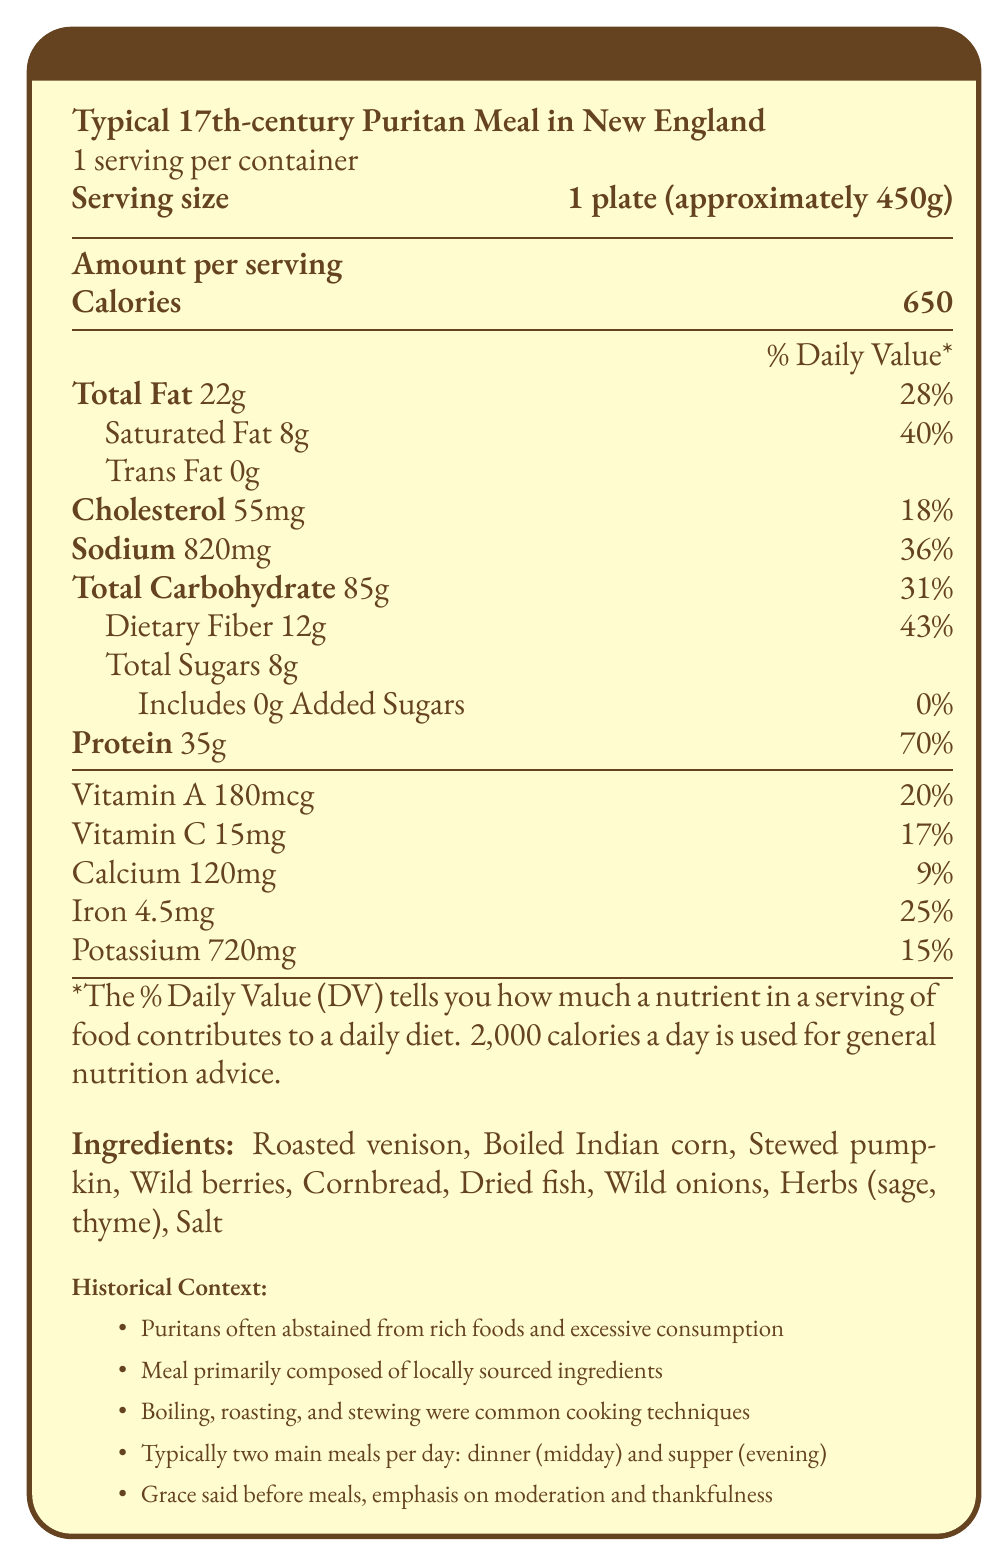what is the serving size of the meal? The document states the serving size as "1 plate (approximately 450g)" under the meal name.
Answer: 1 plate (approximately 450g) how many grams of total fat are there in one serving of this meal? Under the macronutrient section, it states "Total Fat 22g".
Answer: 22g what percentage of the daily value for dietary fiber does one serving provide? The dietary fiber content is listed as 12g with a 43% daily value.
Answer: 43% how much vitamin C does one serving contain? Under the micronutrient section, it states "Vitamin C 15mg".
Answer: 15mg what ingredients are included in the meal? The ingredients are listed at the bottom of the document under the "Ingredients" section.
Answer: Roasted venison, Boiled Indian corn, Stewed pumpkin, Wild berries, Cornbread, Dried fish, Wild onions, Herbs (sage, thyme), Salt how much protein is in one serving, and what percentage of the daily value does it represent? The protein content is listed as "Protein 35g (70%)" in the macronutrient section.
Answer: 35g, 70% how many main meals did Puritans typically have per day? The historical context section mentions that Puritans typically had "two main meals per day: dinner (midday) and supper (evening)".
Answer: 2 which cooking methods were common for Puritans based on the document? The historical context section mentions these cooking techniques: "Boiling, roasting, and stewing were common cooking techniques".
Answer: Boiling, roasting, and stewing how many milligrams of potassium are there in one serving? Under the micronutrient section, it states "Potassium 720mg".
Answer: 720mg based on the nutritional notes, what food preservation method contributed to the meal's sodium content? The nutritional notes state, "Relatively high in sodium due to preservation methods".
Answer: Preservation methods what ingredient is not explicitly listed among the ingredients found in this meal? A. Wild onions B. Butter C. Wild berries D. Salt The ingredients list does not include butter.
Answer: B. Butter how many grams of dietary fiber are present in one serving? A. 8g B. 10g C. 12g D. 15g The dietary fiber is listed as "Dietary Fiber 12g".
Answer: C. 12g is the meal a good source of calcium? The document states that the meal provides 120mg of calcium, which is 9% of the daily value, indicating it is a modest source of calcium.
Answer: Yes summarize the nutrition facts of a typical 17th-century Puritan meal in New England based on the document. The document describes the nutritional information, ingredients, and historical context surrounding a typical Puritan meal, emphasizing the nutritional value and traditional practices.
Answer: The meal provides 650 calories per serving, with significant levels of protein (35g, 70% DV), total fat (22g, 28% DV), and dietary fiber (12g, 43% DV). It includes ingredients such as roasted venison, boiled Indian corn, and berries. The Puritans prepared meals through boiling, roasting, and stewing, focusing on locally sourced ingredients and limited rich foods. what food item was likely scarce and expensive for Puritans? The nutritional notes mention, "Limited added sugars, as sugar was scarce and expensive".
Answer: Sugar how many grams of trans fat are in one serving? The document lists "Trans Fat 0g" in the macronutrient section.
Answer: 0g which of the following vitamins are present in the meal? I. Vitamin A II. Vitamin B12 III. Vitamin C IV. Vitamin E The document lists Vitamin A and Vitamin C under the micronutrient section, but there is no mention of Vitamin B12 or Vitamin E.
Answer: I and III how often were the Puritans likely to consume rich or excessive foods? The historical context mentions that "Puritans often abstained from rich foods and excessive consumption".
Answer: They often abstained from rich foods and excessive consumption. how was the meal predominantly composed? The historical context notes that the meal was "primarily composed of locally sourced ingredients".
Answer: Locally sourced ingredients how did Puritans express their religious beliefs before meals? The historical context mentions that "Grace said before meals, emphasis on moderation and thankfulness".
Answer: Grace said before meals, emphasis on moderation and thankfulness. what is the exact amount of sugar used in the meal? The document lists "Total Sugars 8g" but does not specify the exact sources of the sugar used in the meal.
Answer: Cannot be determined 